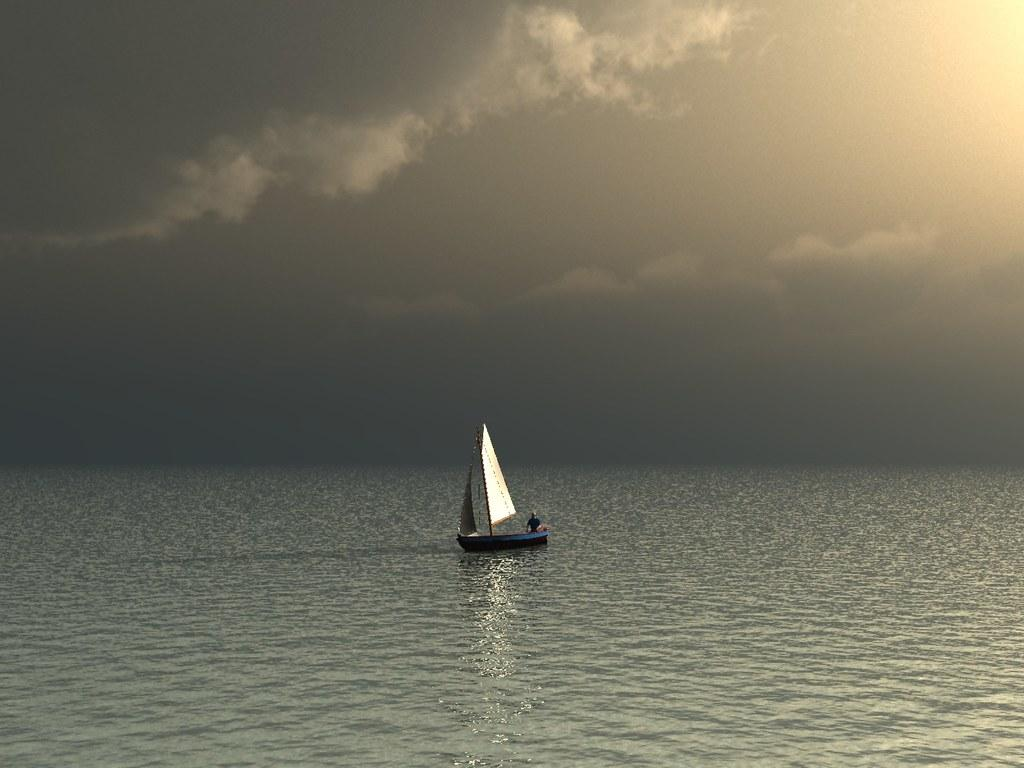What is present in the image that is related to water? There is water in the image. What can be seen floating on the water in the image? There is a boat in the image. Who is on the boat in the image? A person is on the boat in the image. What can be seen in the background of the image? The sky is visible in the background of the image. What is the condition of the sky in the image? The sky is cloudy in the image. What type of tin can be seen floating on the water in the image? There is no tin present in the image; it features water, a boat, and a person on the boat. How is the glue being used in the image? There is no glue present in the image. 